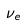Convert formula to latex. <formula><loc_0><loc_0><loc_500><loc_500>\nu _ { e }</formula> 